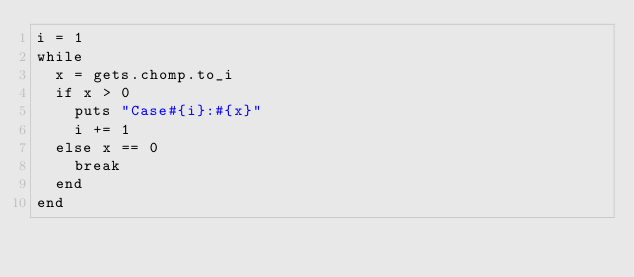Convert code to text. <code><loc_0><loc_0><loc_500><loc_500><_Ruby_>i = 1
while 
  x = gets.chomp.to_i
  if x > 0
    puts "Case#{i}:#{x}"
    i += 1
  else x == 0
    break
  end
end</code> 